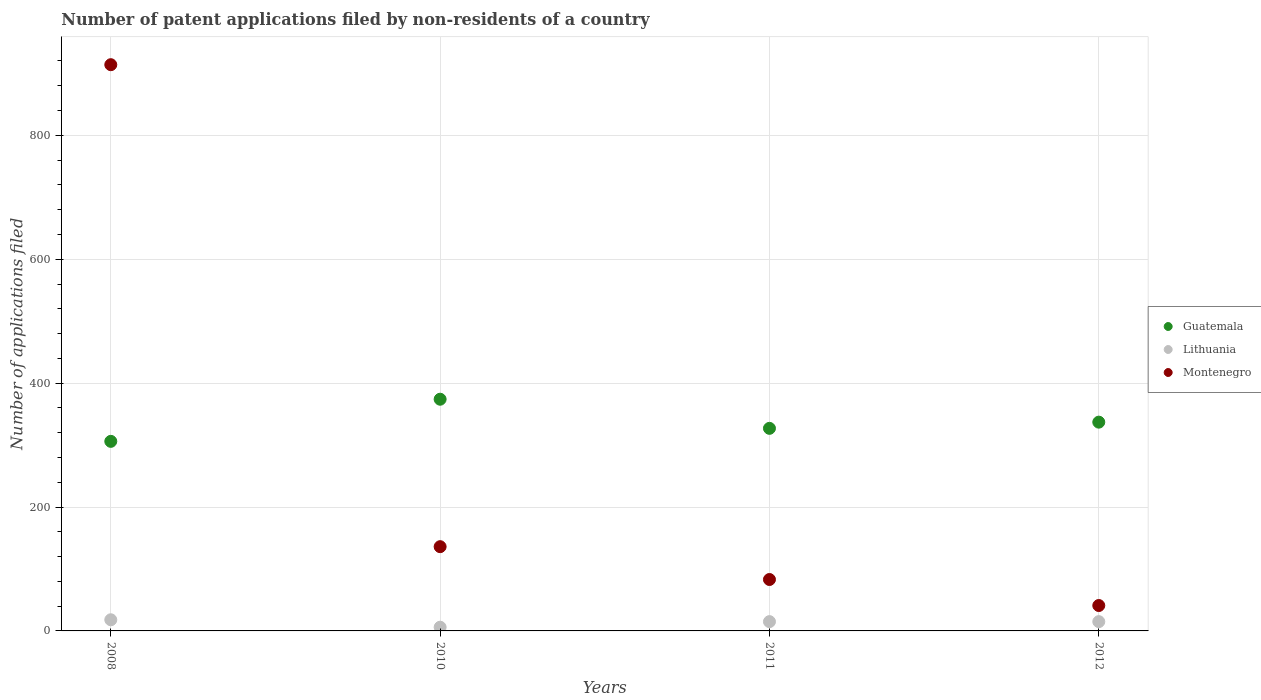How many different coloured dotlines are there?
Provide a short and direct response. 3. What is the number of applications filed in Lithuania in 2012?
Your answer should be very brief. 15. Across all years, what is the maximum number of applications filed in Montenegro?
Your answer should be very brief. 914. Across all years, what is the minimum number of applications filed in Lithuania?
Provide a short and direct response. 6. What is the total number of applications filed in Guatemala in the graph?
Your answer should be very brief. 1344. What is the difference between the number of applications filed in Montenegro in 2008 and that in 2011?
Offer a terse response. 831. What is the difference between the number of applications filed in Lithuania in 2011 and the number of applications filed in Montenegro in 2010?
Provide a short and direct response. -121. What is the average number of applications filed in Montenegro per year?
Make the answer very short. 293.5. In the year 2012, what is the difference between the number of applications filed in Montenegro and number of applications filed in Guatemala?
Your answer should be compact. -296. What is the ratio of the number of applications filed in Montenegro in 2008 to that in 2012?
Provide a succinct answer. 22.29. Is the number of applications filed in Montenegro in 2010 less than that in 2011?
Offer a terse response. No. Is the difference between the number of applications filed in Montenegro in 2008 and 2012 greater than the difference between the number of applications filed in Guatemala in 2008 and 2012?
Ensure brevity in your answer.  Yes. What is the difference between the highest and the second highest number of applications filed in Guatemala?
Give a very brief answer. 37. What is the difference between the highest and the lowest number of applications filed in Montenegro?
Provide a succinct answer. 873. In how many years, is the number of applications filed in Montenegro greater than the average number of applications filed in Montenegro taken over all years?
Offer a very short reply. 1. Is the sum of the number of applications filed in Montenegro in 2010 and 2012 greater than the maximum number of applications filed in Guatemala across all years?
Your answer should be very brief. No. Is it the case that in every year, the sum of the number of applications filed in Montenegro and number of applications filed in Lithuania  is greater than the number of applications filed in Guatemala?
Give a very brief answer. No. Is the number of applications filed in Montenegro strictly less than the number of applications filed in Lithuania over the years?
Your response must be concise. No. What is the difference between two consecutive major ticks on the Y-axis?
Make the answer very short. 200. Are the values on the major ticks of Y-axis written in scientific E-notation?
Your answer should be compact. No. Does the graph contain any zero values?
Keep it short and to the point. No. Does the graph contain grids?
Keep it short and to the point. Yes. Where does the legend appear in the graph?
Give a very brief answer. Center right. What is the title of the graph?
Offer a very short reply. Number of patent applications filed by non-residents of a country. Does "Turkey" appear as one of the legend labels in the graph?
Ensure brevity in your answer.  No. What is the label or title of the Y-axis?
Your answer should be very brief. Number of applications filed. What is the Number of applications filed of Guatemala in 2008?
Keep it short and to the point. 306. What is the Number of applications filed of Lithuania in 2008?
Give a very brief answer. 18. What is the Number of applications filed of Montenegro in 2008?
Your response must be concise. 914. What is the Number of applications filed in Guatemala in 2010?
Keep it short and to the point. 374. What is the Number of applications filed in Montenegro in 2010?
Ensure brevity in your answer.  136. What is the Number of applications filed of Guatemala in 2011?
Your response must be concise. 327. What is the Number of applications filed in Lithuania in 2011?
Give a very brief answer. 15. What is the Number of applications filed of Montenegro in 2011?
Give a very brief answer. 83. What is the Number of applications filed in Guatemala in 2012?
Ensure brevity in your answer.  337. What is the Number of applications filed of Lithuania in 2012?
Keep it short and to the point. 15. What is the Number of applications filed of Montenegro in 2012?
Offer a very short reply. 41. Across all years, what is the maximum Number of applications filed in Guatemala?
Your answer should be very brief. 374. Across all years, what is the maximum Number of applications filed in Lithuania?
Make the answer very short. 18. Across all years, what is the maximum Number of applications filed in Montenegro?
Your answer should be compact. 914. Across all years, what is the minimum Number of applications filed in Guatemala?
Give a very brief answer. 306. Across all years, what is the minimum Number of applications filed of Lithuania?
Your answer should be compact. 6. Across all years, what is the minimum Number of applications filed in Montenegro?
Your answer should be very brief. 41. What is the total Number of applications filed in Guatemala in the graph?
Provide a short and direct response. 1344. What is the total Number of applications filed of Lithuania in the graph?
Your answer should be very brief. 54. What is the total Number of applications filed in Montenegro in the graph?
Make the answer very short. 1174. What is the difference between the Number of applications filed in Guatemala in 2008 and that in 2010?
Keep it short and to the point. -68. What is the difference between the Number of applications filed in Montenegro in 2008 and that in 2010?
Make the answer very short. 778. What is the difference between the Number of applications filed in Guatemala in 2008 and that in 2011?
Provide a short and direct response. -21. What is the difference between the Number of applications filed of Lithuania in 2008 and that in 2011?
Provide a succinct answer. 3. What is the difference between the Number of applications filed of Montenegro in 2008 and that in 2011?
Your answer should be very brief. 831. What is the difference between the Number of applications filed in Guatemala in 2008 and that in 2012?
Offer a terse response. -31. What is the difference between the Number of applications filed in Montenegro in 2008 and that in 2012?
Your response must be concise. 873. What is the difference between the Number of applications filed of Guatemala in 2010 and that in 2011?
Keep it short and to the point. 47. What is the difference between the Number of applications filed of Montenegro in 2010 and that in 2011?
Make the answer very short. 53. What is the difference between the Number of applications filed in Lithuania in 2010 and that in 2012?
Provide a short and direct response. -9. What is the difference between the Number of applications filed in Lithuania in 2011 and that in 2012?
Your answer should be compact. 0. What is the difference between the Number of applications filed of Montenegro in 2011 and that in 2012?
Your response must be concise. 42. What is the difference between the Number of applications filed of Guatemala in 2008 and the Number of applications filed of Lithuania in 2010?
Offer a terse response. 300. What is the difference between the Number of applications filed in Guatemala in 2008 and the Number of applications filed in Montenegro in 2010?
Your answer should be compact. 170. What is the difference between the Number of applications filed of Lithuania in 2008 and the Number of applications filed of Montenegro in 2010?
Make the answer very short. -118. What is the difference between the Number of applications filed in Guatemala in 2008 and the Number of applications filed in Lithuania in 2011?
Your response must be concise. 291. What is the difference between the Number of applications filed in Guatemala in 2008 and the Number of applications filed in Montenegro in 2011?
Your answer should be very brief. 223. What is the difference between the Number of applications filed in Lithuania in 2008 and the Number of applications filed in Montenegro in 2011?
Your answer should be very brief. -65. What is the difference between the Number of applications filed in Guatemala in 2008 and the Number of applications filed in Lithuania in 2012?
Your answer should be compact. 291. What is the difference between the Number of applications filed in Guatemala in 2008 and the Number of applications filed in Montenegro in 2012?
Ensure brevity in your answer.  265. What is the difference between the Number of applications filed of Lithuania in 2008 and the Number of applications filed of Montenegro in 2012?
Offer a very short reply. -23. What is the difference between the Number of applications filed in Guatemala in 2010 and the Number of applications filed in Lithuania in 2011?
Your response must be concise. 359. What is the difference between the Number of applications filed of Guatemala in 2010 and the Number of applications filed of Montenegro in 2011?
Your answer should be very brief. 291. What is the difference between the Number of applications filed of Lithuania in 2010 and the Number of applications filed of Montenegro in 2011?
Give a very brief answer. -77. What is the difference between the Number of applications filed in Guatemala in 2010 and the Number of applications filed in Lithuania in 2012?
Give a very brief answer. 359. What is the difference between the Number of applications filed of Guatemala in 2010 and the Number of applications filed of Montenegro in 2012?
Your answer should be very brief. 333. What is the difference between the Number of applications filed of Lithuania in 2010 and the Number of applications filed of Montenegro in 2012?
Ensure brevity in your answer.  -35. What is the difference between the Number of applications filed of Guatemala in 2011 and the Number of applications filed of Lithuania in 2012?
Your answer should be compact. 312. What is the difference between the Number of applications filed of Guatemala in 2011 and the Number of applications filed of Montenegro in 2012?
Provide a short and direct response. 286. What is the difference between the Number of applications filed of Lithuania in 2011 and the Number of applications filed of Montenegro in 2012?
Ensure brevity in your answer.  -26. What is the average Number of applications filed in Guatemala per year?
Your response must be concise. 336. What is the average Number of applications filed in Lithuania per year?
Give a very brief answer. 13.5. What is the average Number of applications filed in Montenegro per year?
Provide a succinct answer. 293.5. In the year 2008, what is the difference between the Number of applications filed in Guatemala and Number of applications filed in Lithuania?
Offer a very short reply. 288. In the year 2008, what is the difference between the Number of applications filed in Guatemala and Number of applications filed in Montenegro?
Your answer should be compact. -608. In the year 2008, what is the difference between the Number of applications filed in Lithuania and Number of applications filed in Montenegro?
Your response must be concise. -896. In the year 2010, what is the difference between the Number of applications filed in Guatemala and Number of applications filed in Lithuania?
Provide a succinct answer. 368. In the year 2010, what is the difference between the Number of applications filed in Guatemala and Number of applications filed in Montenegro?
Provide a short and direct response. 238. In the year 2010, what is the difference between the Number of applications filed of Lithuania and Number of applications filed of Montenegro?
Your answer should be very brief. -130. In the year 2011, what is the difference between the Number of applications filed in Guatemala and Number of applications filed in Lithuania?
Give a very brief answer. 312. In the year 2011, what is the difference between the Number of applications filed of Guatemala and Number of applications filed of Montenegro?
Keep it short and to the point. 244. In the year 2011, what is the difference between the Number of applications filed of Lithuania and Number of applications filed of Montenegro?
Provide a succinct answer. -68. In the year 2012, what is the difference between the Number of applications filed in Guatemala and Number of applications filed in Lithuania?
Your response must be concise. 322. In the year 2012, what is the difference between the Number of applications filed in Guatemala and Number of applications filed in Montenegro?
Offer a terse response. 296. In the year 2012, what is the difference between the Number of applications filed in Lithuania and Number of applications filed in Montenegro?
Make the answer very short. -26. What is the ratio of the Number of applications filed of Guatemala in 2008 to that in 2010?
Ensure brevity in your answer.  0.82. What is the ratio of the Number of applications filed of Montenegro in 2008 to that in 2010?
Provide a short and direct response. 6.72. What is the ratio of the Number of applications filed of Guatemala in 2008 to that in 2011?
Give a very brief answer. 0.94. What is the ratio of the Number of applications filed in Lithuania in 2008 to that in 2011?
Ensure brevity in your answer.  1.2. What is the ratio of the Number of applications filed of Montenegro in 2008 to that in 2011?
Keep it short and to the point. 11.01. What is the ratio of the Number of applications filed in Guatemala in 2008 to that in 2012?
Make the answer very short. 0.91. What is the ratio of the Number of applications filed of Lithuania in 2008 to that in 2012?
Offer a terse response. 1.2. What is the ratio of the Number of applications filed of Montenegro in 2008 to that in 2012?
Keep it short and to the point. 22.29. What is the ratio of the Number of applications filed in Guatemala in 2010 to that in 2011?
Provide a short and direct response. 1.14. What is the ratio of the Number of applications filed in Montenegro in 2010 to that in 2011?
Ensure brevity in your answer.  1.64. What is the ratio of the Number of applications filed of Guatemala in 2010 to that in 2012?
Give a very brief answer. 1.11. What is the ratio of the Number of applications filed of Lithuania in 2010 to that in 2012?
Your answer should be compact. 0.4. What is the ratio of the Number of applications filed in Montenegro in 2010 to that in 2012?
Provide a short and direct response. 3.32. What is the ratio of the Number of applications filed of Guatemala in 2011 to that in 2012?
Your answer should be compact. 0.97. What is the ratio of the Number of applications filed of Montenegro in 2011 to that in 2012?
Offer a very short reply. 2.02. What is the difference between the highest and the second highest Number of applications filed of Montenegro?
Offer a very short reply. 778. What is the difference between the highest and the lowest Number of applications filed of Lithuania?
Offer a terse response. 12. What is the difference between the highest and the lowest Number of applications filed of Montenegro?
Your answer should be very brief. 873. 